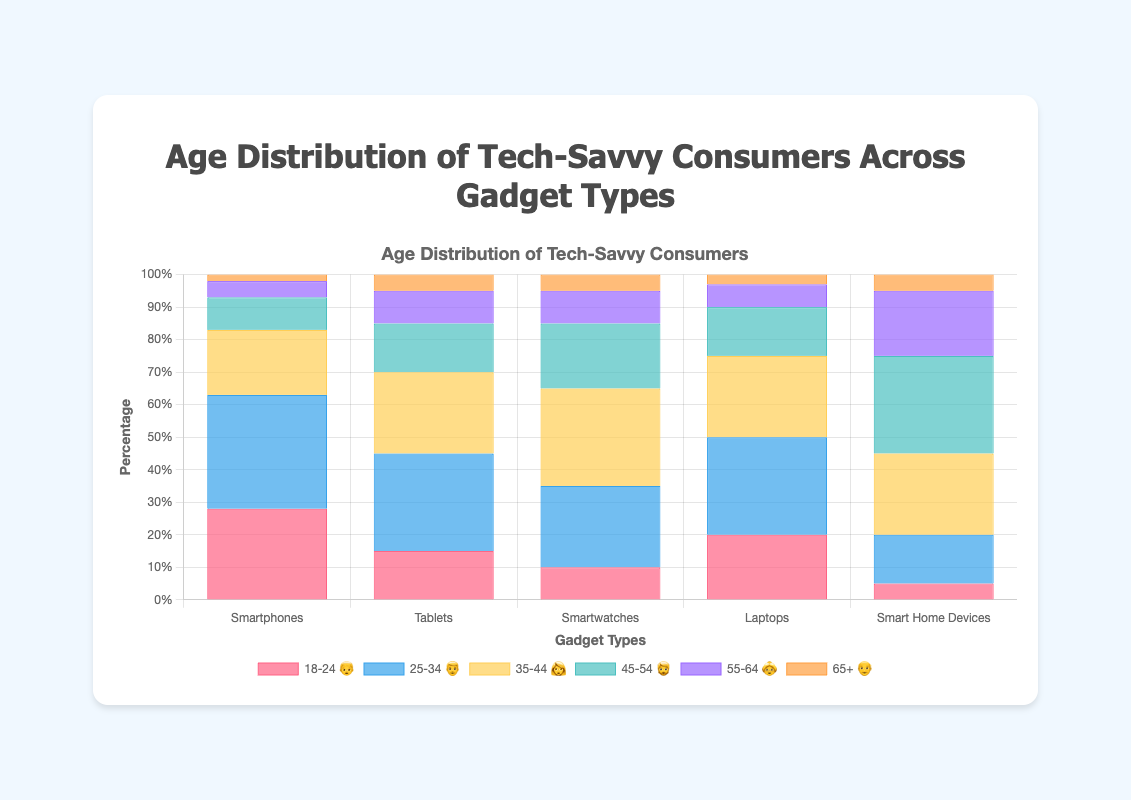What is the title of the chart? The title of the chart is displayed prominently at the top and states the content of the chart.
Answer: Age Distribution of Tech-Savvy Consumers Across Gadget Types Which age group has the highest percentage for Smartphones? The bar chart shows different colored segments for each age group. The tallest bar segment for Smartphones is the one representing "25-34 👨" which is 35%.
Answer: 25-34 👨 Which gadget type has the lowest percentage of users aged 18-24 👦? By observing the bars for the 18-24 👦 age group, the gadget type with the shortest bar segment in this category is "Smart Home Devices," at 5%.
Answer: Smart Home Devices How do the percentages of the age group 35-44 👩 compare for Tablets and Smartwatches? The bar segment representing 35-44 👩 for Tablets is 25%, while for Smartwatches it is 30%. A comparison shows that the percentage for Smartwatches is higher.
Answer: Smartwatches Sum the percentage of users aged 55+ 👴👵 for Laptops. The segments for ages 55-64 👵 and 65+ 👴 for Laptops are 7% and 3% respectively. Adding them together gives 7% + 3% = 10%.
Answer: 10% Which gadget type has the most evenly distributed age groups? To find the most evenly distributed age groups, we look for the gadget type whose bars have a more uniform height for all age groups. "Smart Home Devices" follows this pattern closer than others, with less drastic changes between bar heights.
Answer: Smart Home Devices What percentage of users for Tablets are aged 45-54 🧔? Observing the bar segment for the 45-54 🧔 age group under Tablets, the percentage is 15%.
Answer: 15% Which age group is the least represented in the Smartwatches category? The smallest bar segment for Smartwatches is the one for the 65+ 👴 age group, representing 5%.
Answer: 65+ 👴 Compare the percentages of users aged 18-24 👦 and 25-34 👨 for Smart Home Devices. The percentages for ages 18-24 👦 and 25-34 👨 in the Smart Home Devices category are 5% and 15% respectively. The percentage for 25-34 👨 is higher by 10%.
Answer: 25-34 👨 